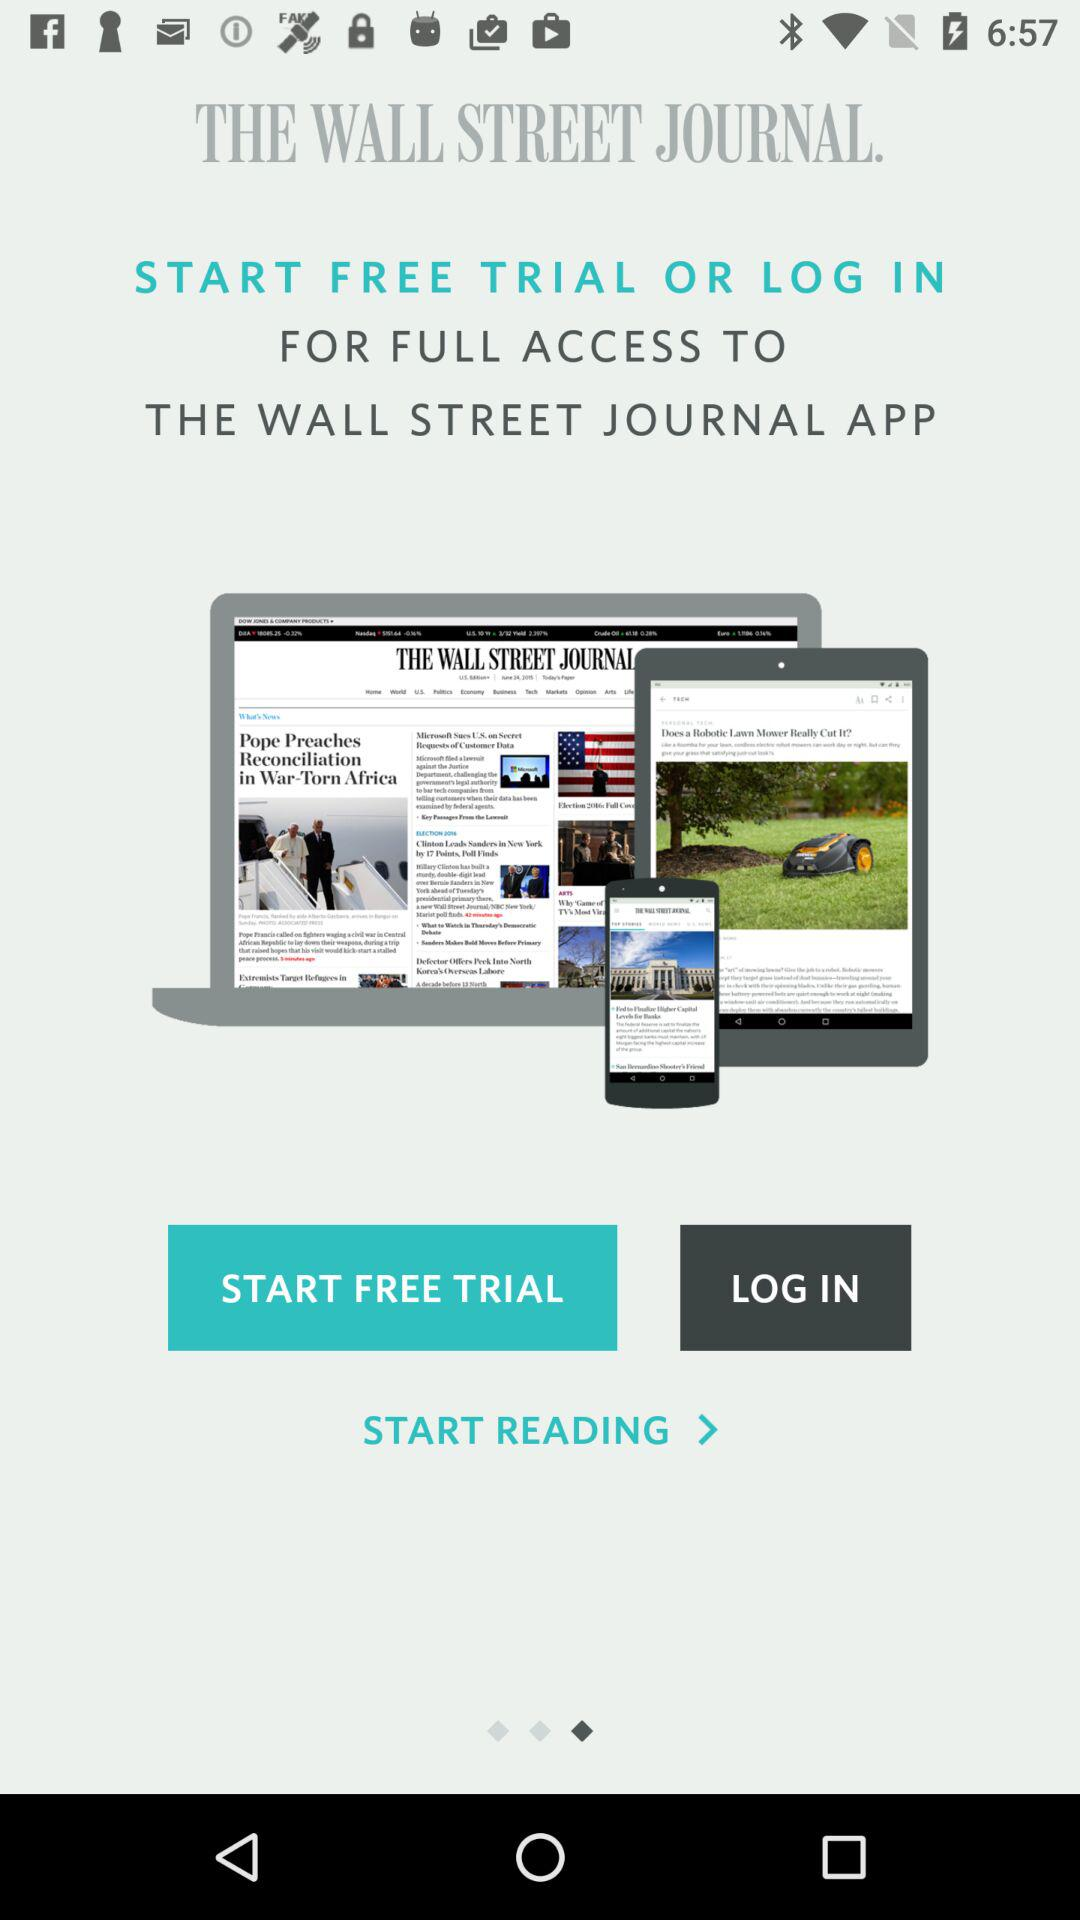What is the application name? The application name is "THE WALL STREET JOURNAL". 